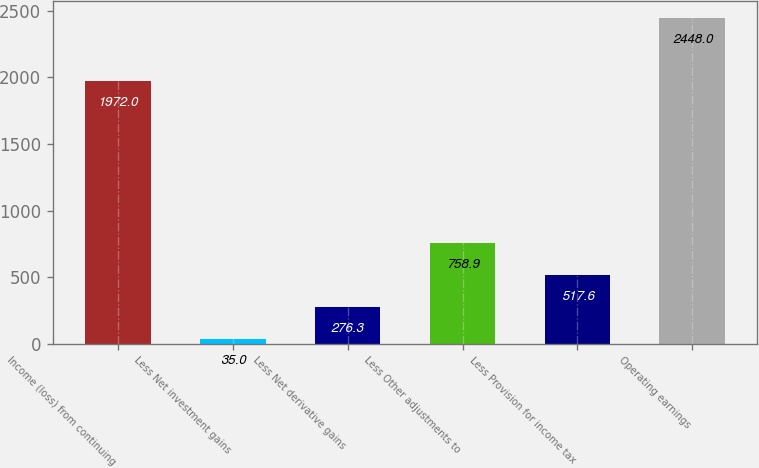Convert chart. <chart><loc_0><loc_0><loc_500><loc_500><bar_chart><fcel>Income (loss) from continuing<fcel>Less Net investment gains<fcel>Less Net derivative gains<fcel>Less Other adjustments to<fcel>Less Provision for income tax<fcel>Operating earnings<nl><fcel>1972<fcel>35<fcel>276.3<fcel>758.9<fcel>517.6<fcel>2448<nl></chart> 